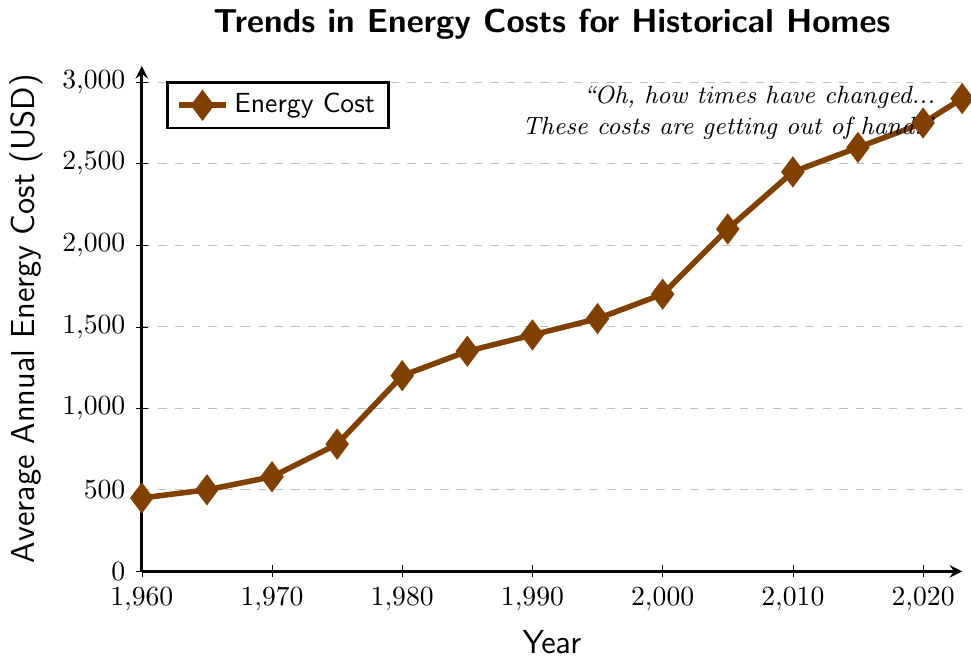What is the average energy cost in the 1980s? The data points for the 1980s are 1200 (1980) and 1350 (1985). To find the average, sum the values: 1200 + 1350 = 2550, then divide by the number of values: 2550 / 2 = 1275
Answer: 1275 How does the energy cost in 2023 compare to that in 1970? The energy cost in 2023 is 2900, and in 1970 it is 580. Since 2900 > 580, the cost in 2023 is higher.
Answer: Higher What is the percentage increase in energy costs from 1960 to 1980? The cost in 1960 is 450 and in 1980 it is 1200. The increase is 1200 - 450 = 750. The percentage increase is (750 / 450) * 100 = 166.67%.
Answer: 166.67% Between which years did the energy costs see the sharpest increase? Observing the data points, the largest increase occurs between 1975 (780) and 1980 (1200). The increase is 1200 - 780 = 420.
Answer: 1975-1980 What is the total increase in energy costs from 1960 to 2023? The cost in 1960 is 450 and in 2023 it is 2900. The total increase is 2900 - 450 = 2450.
Answer: 2450 What's the median energy cost value for the dataset? To find the median, list the values in order and find the middle one. The dataset has 14 values: 450, 500, 580, 780, 1200, 1350, 1450, 1550, 1700, 2100, 2450, 2600, 2750, and 2900. The median is between the 7th (1450) and 8th (1550) values. The median is (1450 + 1550) / 2 = 1500.
Answer: 1500 By what factor have energy costs increased from 1960 to 2023? The cost in 1960 is 450 and in 2023 it is 2900. The factor of increase is 2900 / 450 = 6.44.
Answer: 6.44 Is there a year between 1960 and 2023 where the energy cost was greater than 2000 USD? Yes, in 2005 the energy cost was 2100, which is greater than 2000.
Answer: Yes Which decade saw the least increase in energy costs? Calculate the increase for each decade: 
1960s: 1965 - 1960 (500 - 450 = 50), 
1970s: 1975 - 1970 (780 - 580 = 200), 
1980s: 1985 - 1980 (1350 - 1200 = 150), 
1990s: 1995 - 1990 (1550 - 1450 = 100), 
2000s: 2005 - 2000 (2100 - 1700 = 400), 
2010s: 2015 - 2010 (2600 - 2450 = 150), 
2020s: 2023 - 2020 (2900 - 2750 = 150). The 1960s saw the least increase at 50 USD.
Answer: 1960s What visual element indicates the increasing cost trend over the years? The line on the graph rises progressively from left to right, indicating an increasing trend. The markers (diamonds) also rise higher on the y-axis as the years progress.
Answer: Rising line and markers 